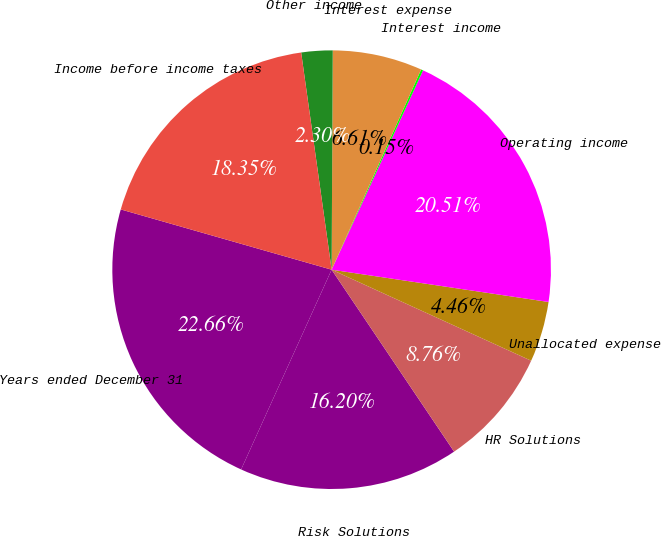<chart> <loc_0><loc_0><loc_500><loc_500><pie_chart><fcel>Years ended December 31<fcel>Risk Solutions<fcel>HR Solutions<fcel>Unallocated expense<fcel>Operating income<fcel>Interest income<fcel>Interest expense<fcel>Other income<fcel>Income before income taxes<nl><fcel>22.66%<fcel>16.2%<fcel>8.76%<fcel>4.46%<fcel>20.51%<fcel>0.15%<fcel>6.61%<fcel>2.3%<fcel>18.35%<nl></chart> 